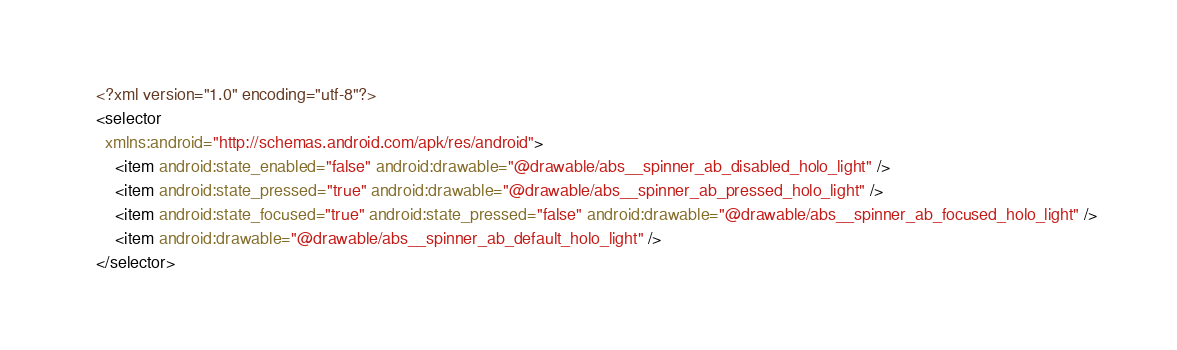Convert code to text. <code><loc_0><loc_0><loc_500><loc_500><_XML_><?xml version="1.0" encoding="utf-8"?>
<selector
  xmlns:android="http://schemas.android.com/apk/res/android">
    <item android:state_enabled="false" android:drawable="@drawable/abs__spinner_ab_disabled_holo_light" />
    <item android:state_pressed="true" android:drawable="@drawable/abs__spinner_ab_pressed_holo_light" />
    <item android:state_focused="true" android:state_pressed="false" android:drawable="@drawable/abs__spinner_ab_focused_holo_light" />
    <item android:drawable="@drawable/abs__spinner_ab_default_holo_light" />
</selector>
</code> 